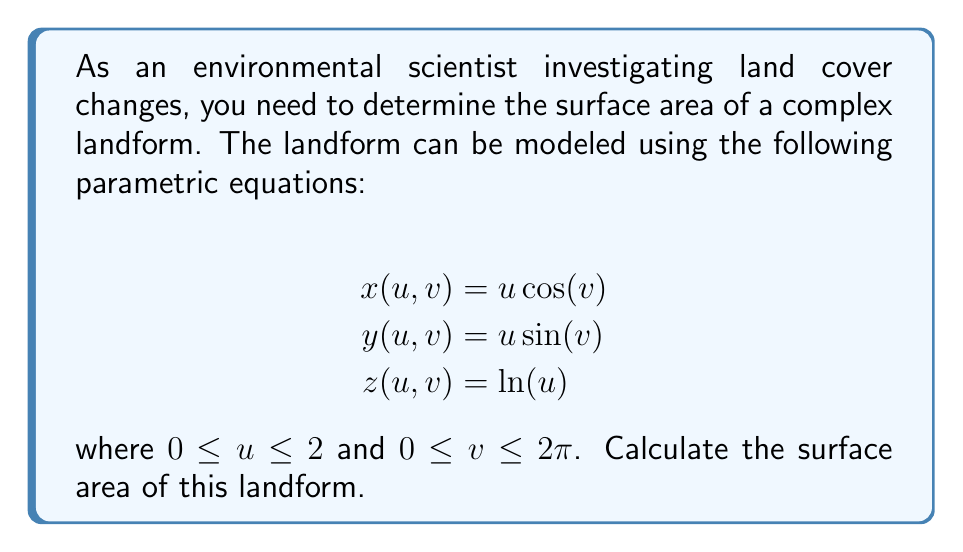Help me with this question. To find the surface area of a parametric surface, we need to use the surface area formula:

$$A = \int\int_D \left|\frac{\partial \mathbf{r}}{\partial u} \times \frac{\partial \mathbf{r}}{\partial v}\right| \, du \, dv$$

where $\mathbf{r}(u,v) = (x(u,v), y(u,v), z(u,v))$.

Step 1: Calculate partial derivatives
$$\frac{\partial \mathbf{r}}{\partial u} = (\cos(v), \sin(v), \frac{1}{u})$$
$$\frac{\partial \mathbf{r}}{\partial v} = (-u\sin(v), u\cos(v), 0)$$

Step 2: Calculate the cross product
$$\frac{\partial \mathbf{r}}{\partial u} \times \frac{\partial \mathbf{r}}{\partial v} = (u\sin(v), -u\cos(v), u)$$

Step 3: Calculate the magnitude of the cross product
$$\left|\frac{\partial \mathbf{r}}{\partial u} \times \frac{\partial \mathbf{r}}{\partial v}\right| = \sqrt{u^2\sin^2(v) + u^2\cos^2(v) + u^2} = u\sqrt{2}$$

Step 4: Set up the double integral
$$A = \int_0^{2\pi} \int_0^2 u\sqrt{2} \, du \, dv$$

Step 5: Evaluate the inner integral
$$A = \int_0^{2\pi} \left[\frac{u^2\sqrt{2}}{2}\right]_0^2 \, dv = \int_0^{2\pi} 2\sqrt{2} \, dv$$

Step 6: Evaluate the outer integral
$$A = 2\sqrt{2} \cdot 2\pi = 4\sqrt{2}\pi$$

Therefore, the surface area of the landform is $4\sqrt{2}\pi$ square units.
Answer: $4\sqrt{2}\pi$ square units 